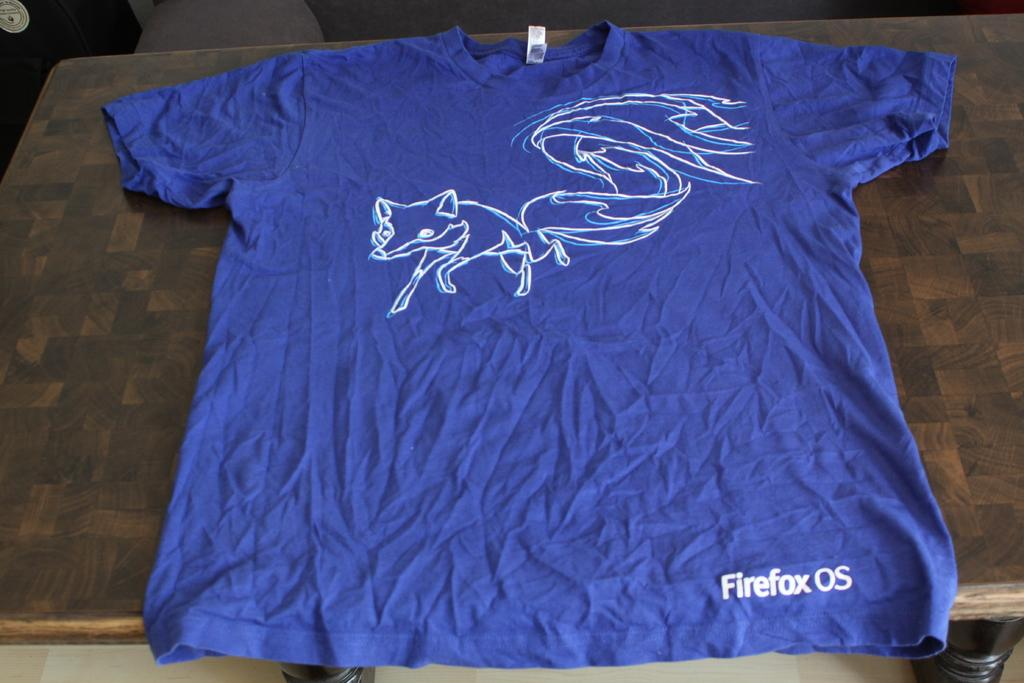<image>
Create a compact narrative representing the image presented. A brilliant blue, wrinkled t-shirt has a white fox sketched on it and Firefox on the bottom edge. 